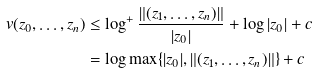<formula> <loc_0><loc_0><loc_500><loc_500>v ( z _ { 0 } , \dots , z _ { n } ) & \leq \log ^ { + } \frac { \| ( z _ { 1 } , \dots , z _ { n } ) \| } { | z _ { 0 } | } + \log | z _ { 0 } | + c \\ & = \log \max \{ | z _ { 0 } | , \| ( z _ { 1 } , \dots , z _ { n } ) \| \} + c</formula> 